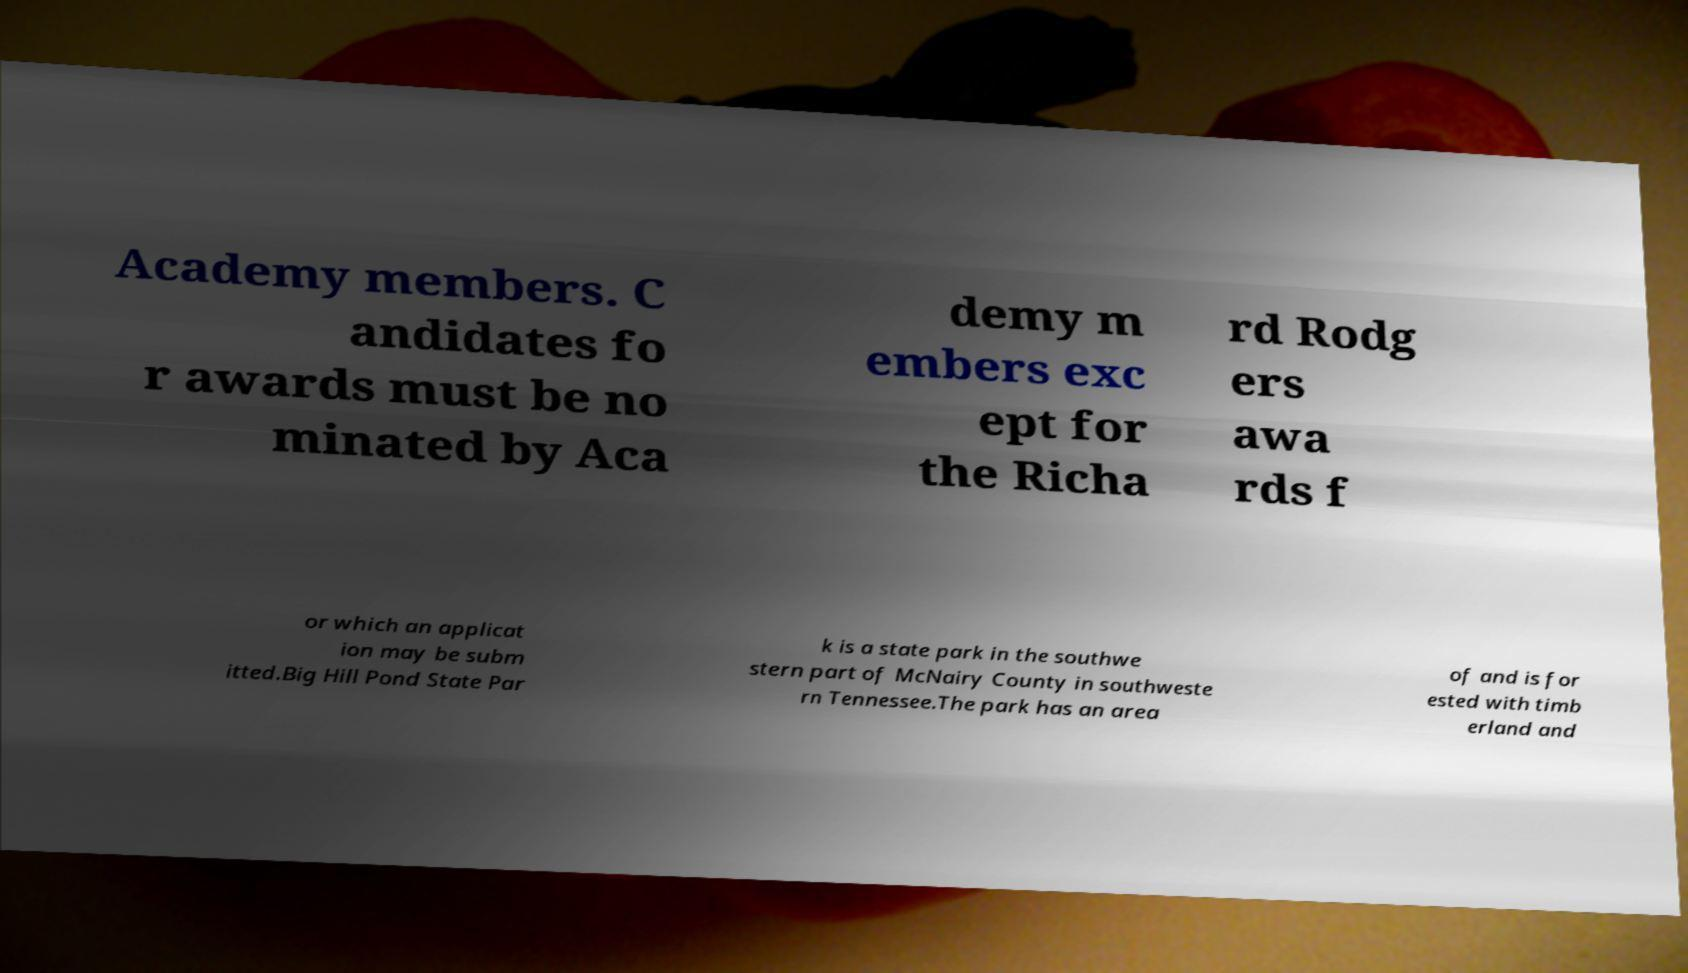Please identify and transcribe the text found in this image. Academy members. C andidates fo r awards must be no minated by Aca demy m embers exc ept for the Richa rd Rodg ers awa rds f or which an applicat ion may be subm itted.Big Hill Pond State Par k is a state park in the southwe stern part of McNairy County in southweste rn Tennessee.The park has an area of and is for ested with timb erland and 